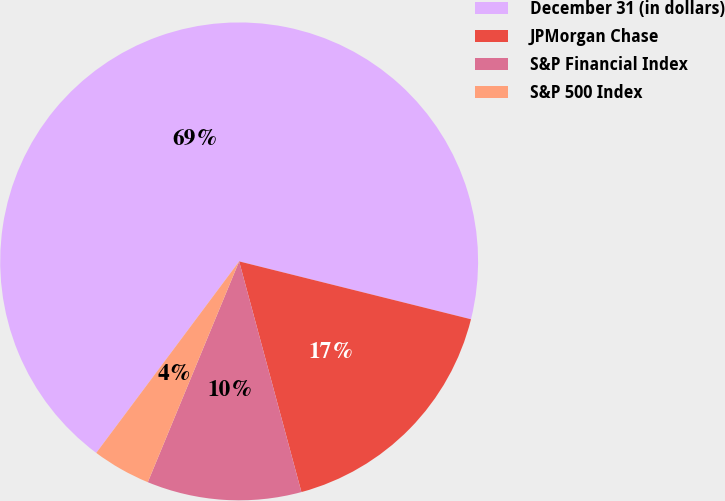Convert chart to OTSL. <chart><loc_0><loc_0><loc_500><loc_500><pie_chart><fcel>December 31 (in dollars)<fcel>JPMorgan Chase<fcel>S&P Financial Index<fcel>S&P 500 Index<nl><fcel>68.69%<fcel>16.91%<fcel>10.44%<fcel>3.96%<nl></chart> 